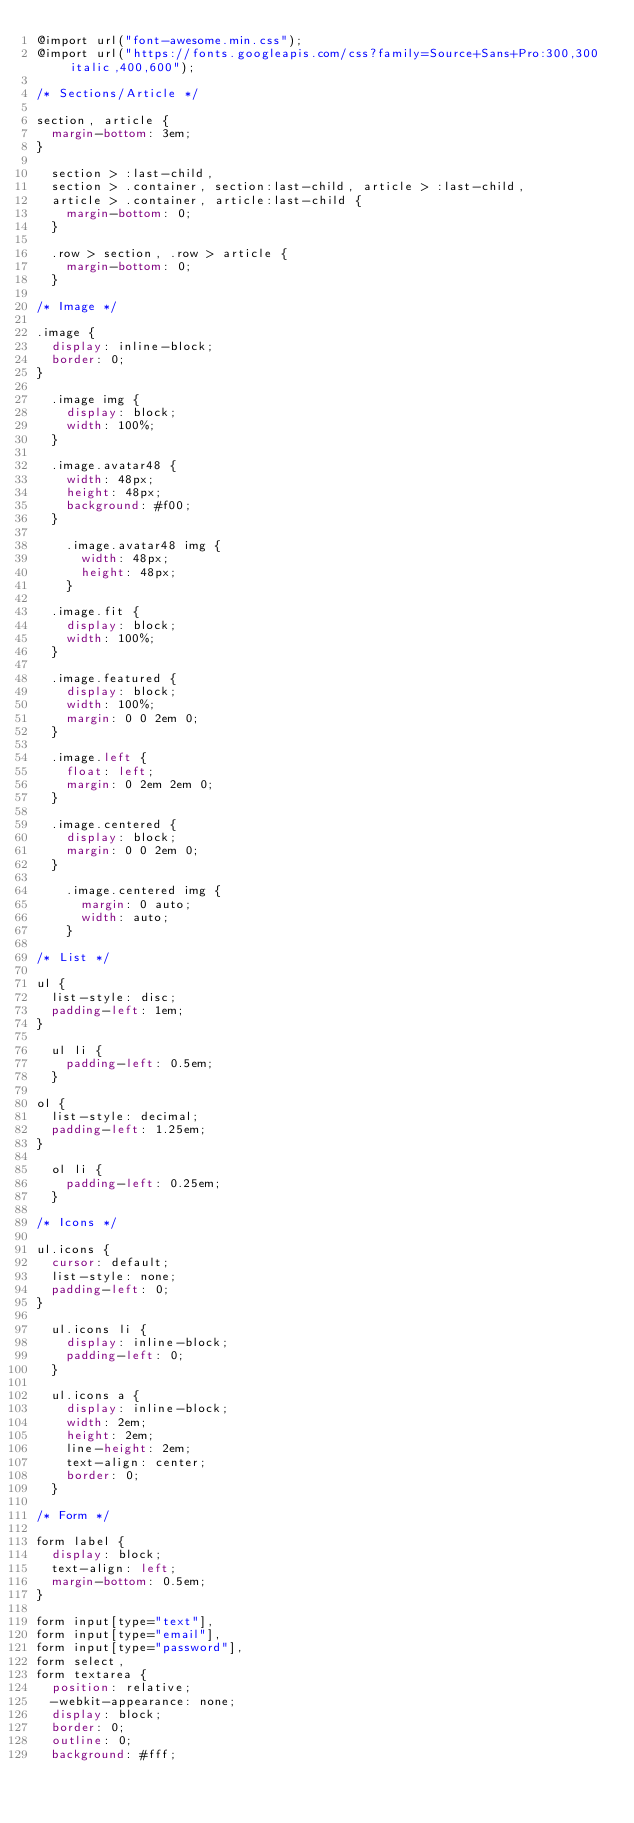<code> <loc_0><loc_0><loc_500><loc_500><_CSS_>@import url("font-awesome.min.css");
@import url("https://fonts.googleapis.com/css?family=Source+Sans+Pro:300,300italic,400,600");

/* Sections/Article */

section, article {
  margin-bottom: 3em;
}

  section > :last-child,
  section > .container, section:last-child, article > :last-child,
  article > .container, article:last-child {
    margin-bottom: 0;
  }

  .row > section, .row > article {
    margin-bottom: 0;
  }

/* Image */

.image {
  display: inline-block;
  border: 0;
}

  .image img {
    display: block;
    width: 100%;
  }

  .image.avatar48 {
    width: 48px;
    height: 48px;
    background: #f00;
  }

    .image.avatar48 img {
      width: 48px;
      height: 48px;
    }

  .image.fit {
    display: block;
    width: 100%;
  }

  .image.featured {
    display: block;
    width: 100%;
    margin: 0 0 2em 0;
  }

  .image.left {
    float: left;
    margin: 0 2em 2em 0;
  }

  .image.centered {
    display: block;
    margin: 0 0 2em 0;
  }

    .image.centered img {
      margin: 0 auto;
      width: auto;
    }

/* List */

ul {
  list-style: disc;
  padding-left: 1em;
}

  ul li {
    padding-left: 0.5em;
  }

ol {
  list-style: decimal;
  padding-left: 1.25em;
}

  ol li {
    padding-left: 0.25em;
  }

/* Icons */

ul.icons {
  cursor: default;
  list-style: none;
  padding-left: 0;
}

  ul.icons li {
    display: inline-block;
    padding-left: 0;
  }

  ul.icons a {
    display: inline-block;
    width: 2em;
    height: 2em;
    line-height: 2em;
    text-align: center;
    border: 0;
  }

/* Form */

form label {
  display: block;
  text-align: left;
  margin-bottom: 0.5em;
}

form input[type="text"],
form input[type="email"],
form input[type="password"],
form select,
form textarea {
  position: relative;
  -webkit-appearance: none;
  display: block;
  border: 0;
  outline: 0;
  background: #fff;</code> 